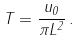<formula> <loc_0><loc_0><loc_500><loc_500>T = \frac { u _ { 0 } } { \pi L ^ { 2 } } \, .</formula> 